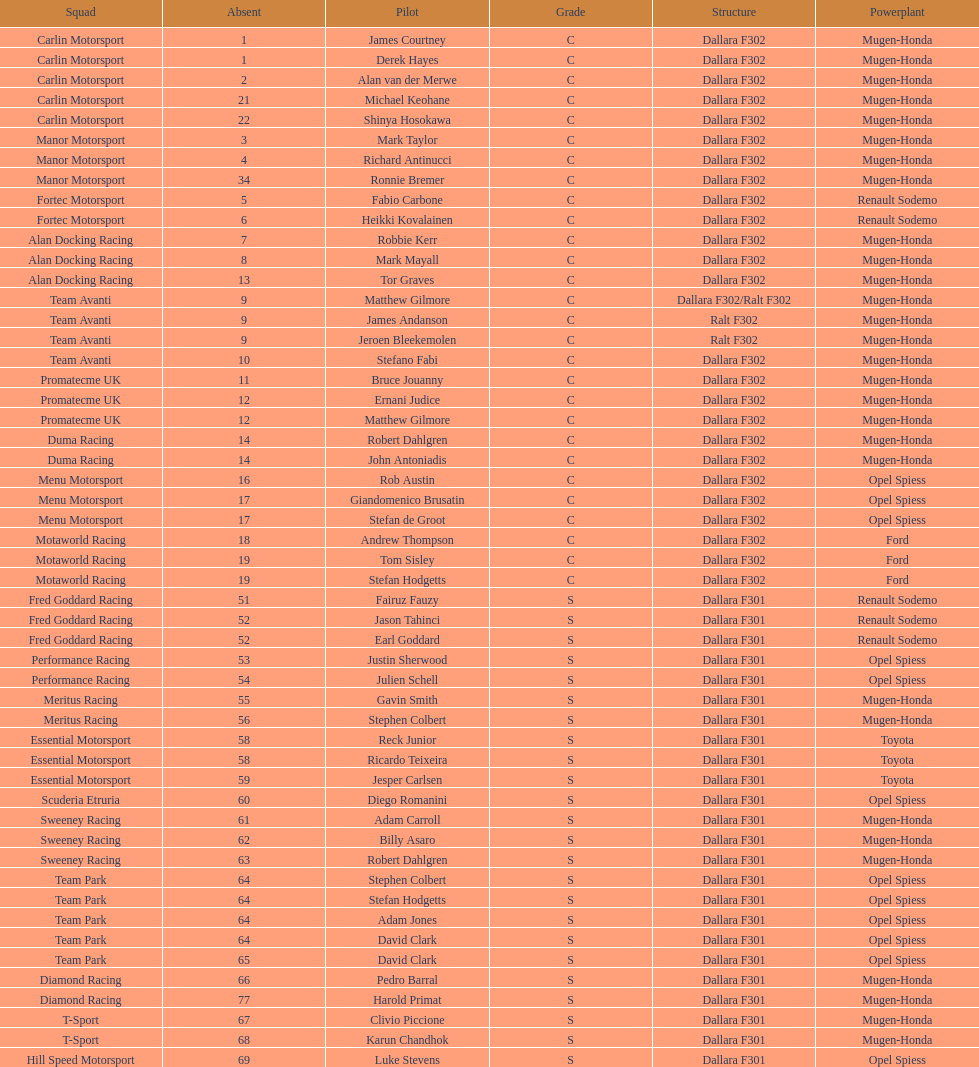Which engine was used the most by teams this season? Mugen-Honda. 